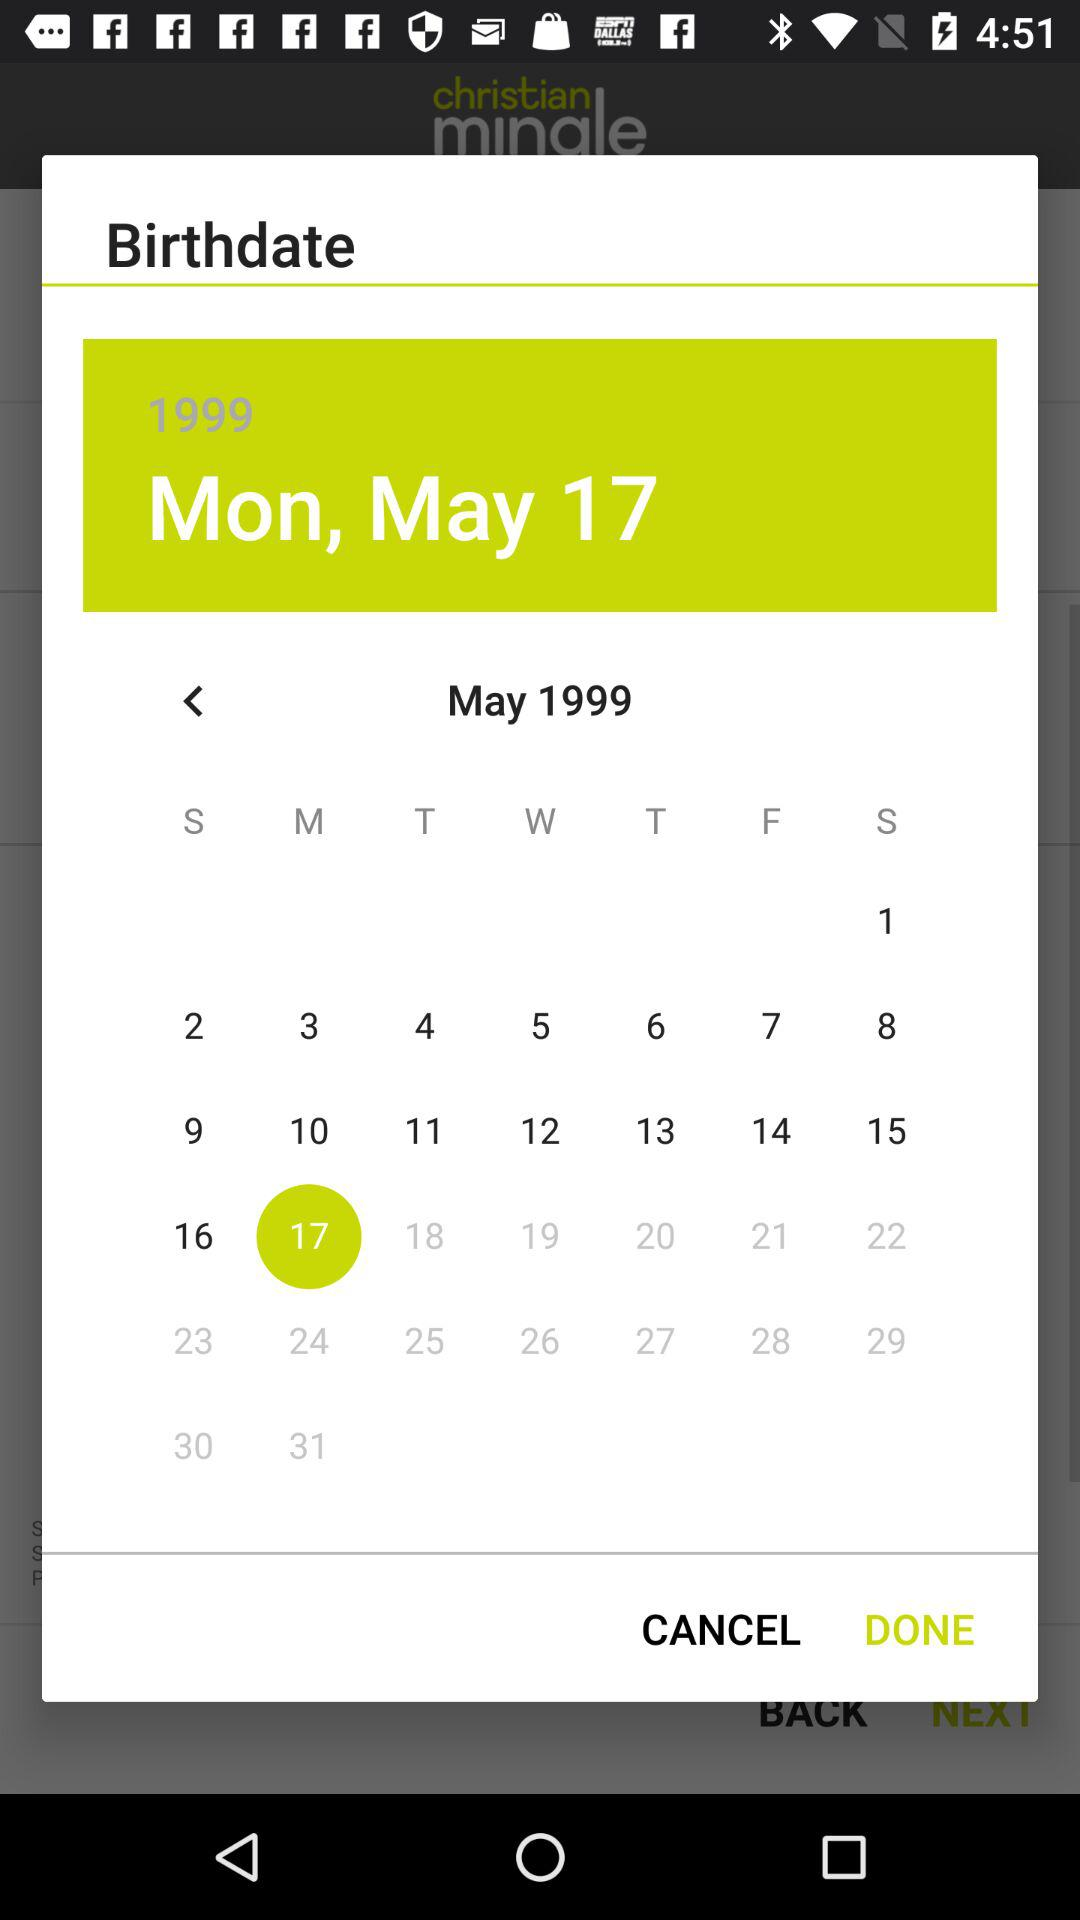What is the day on May 17th? The day is Monday. 